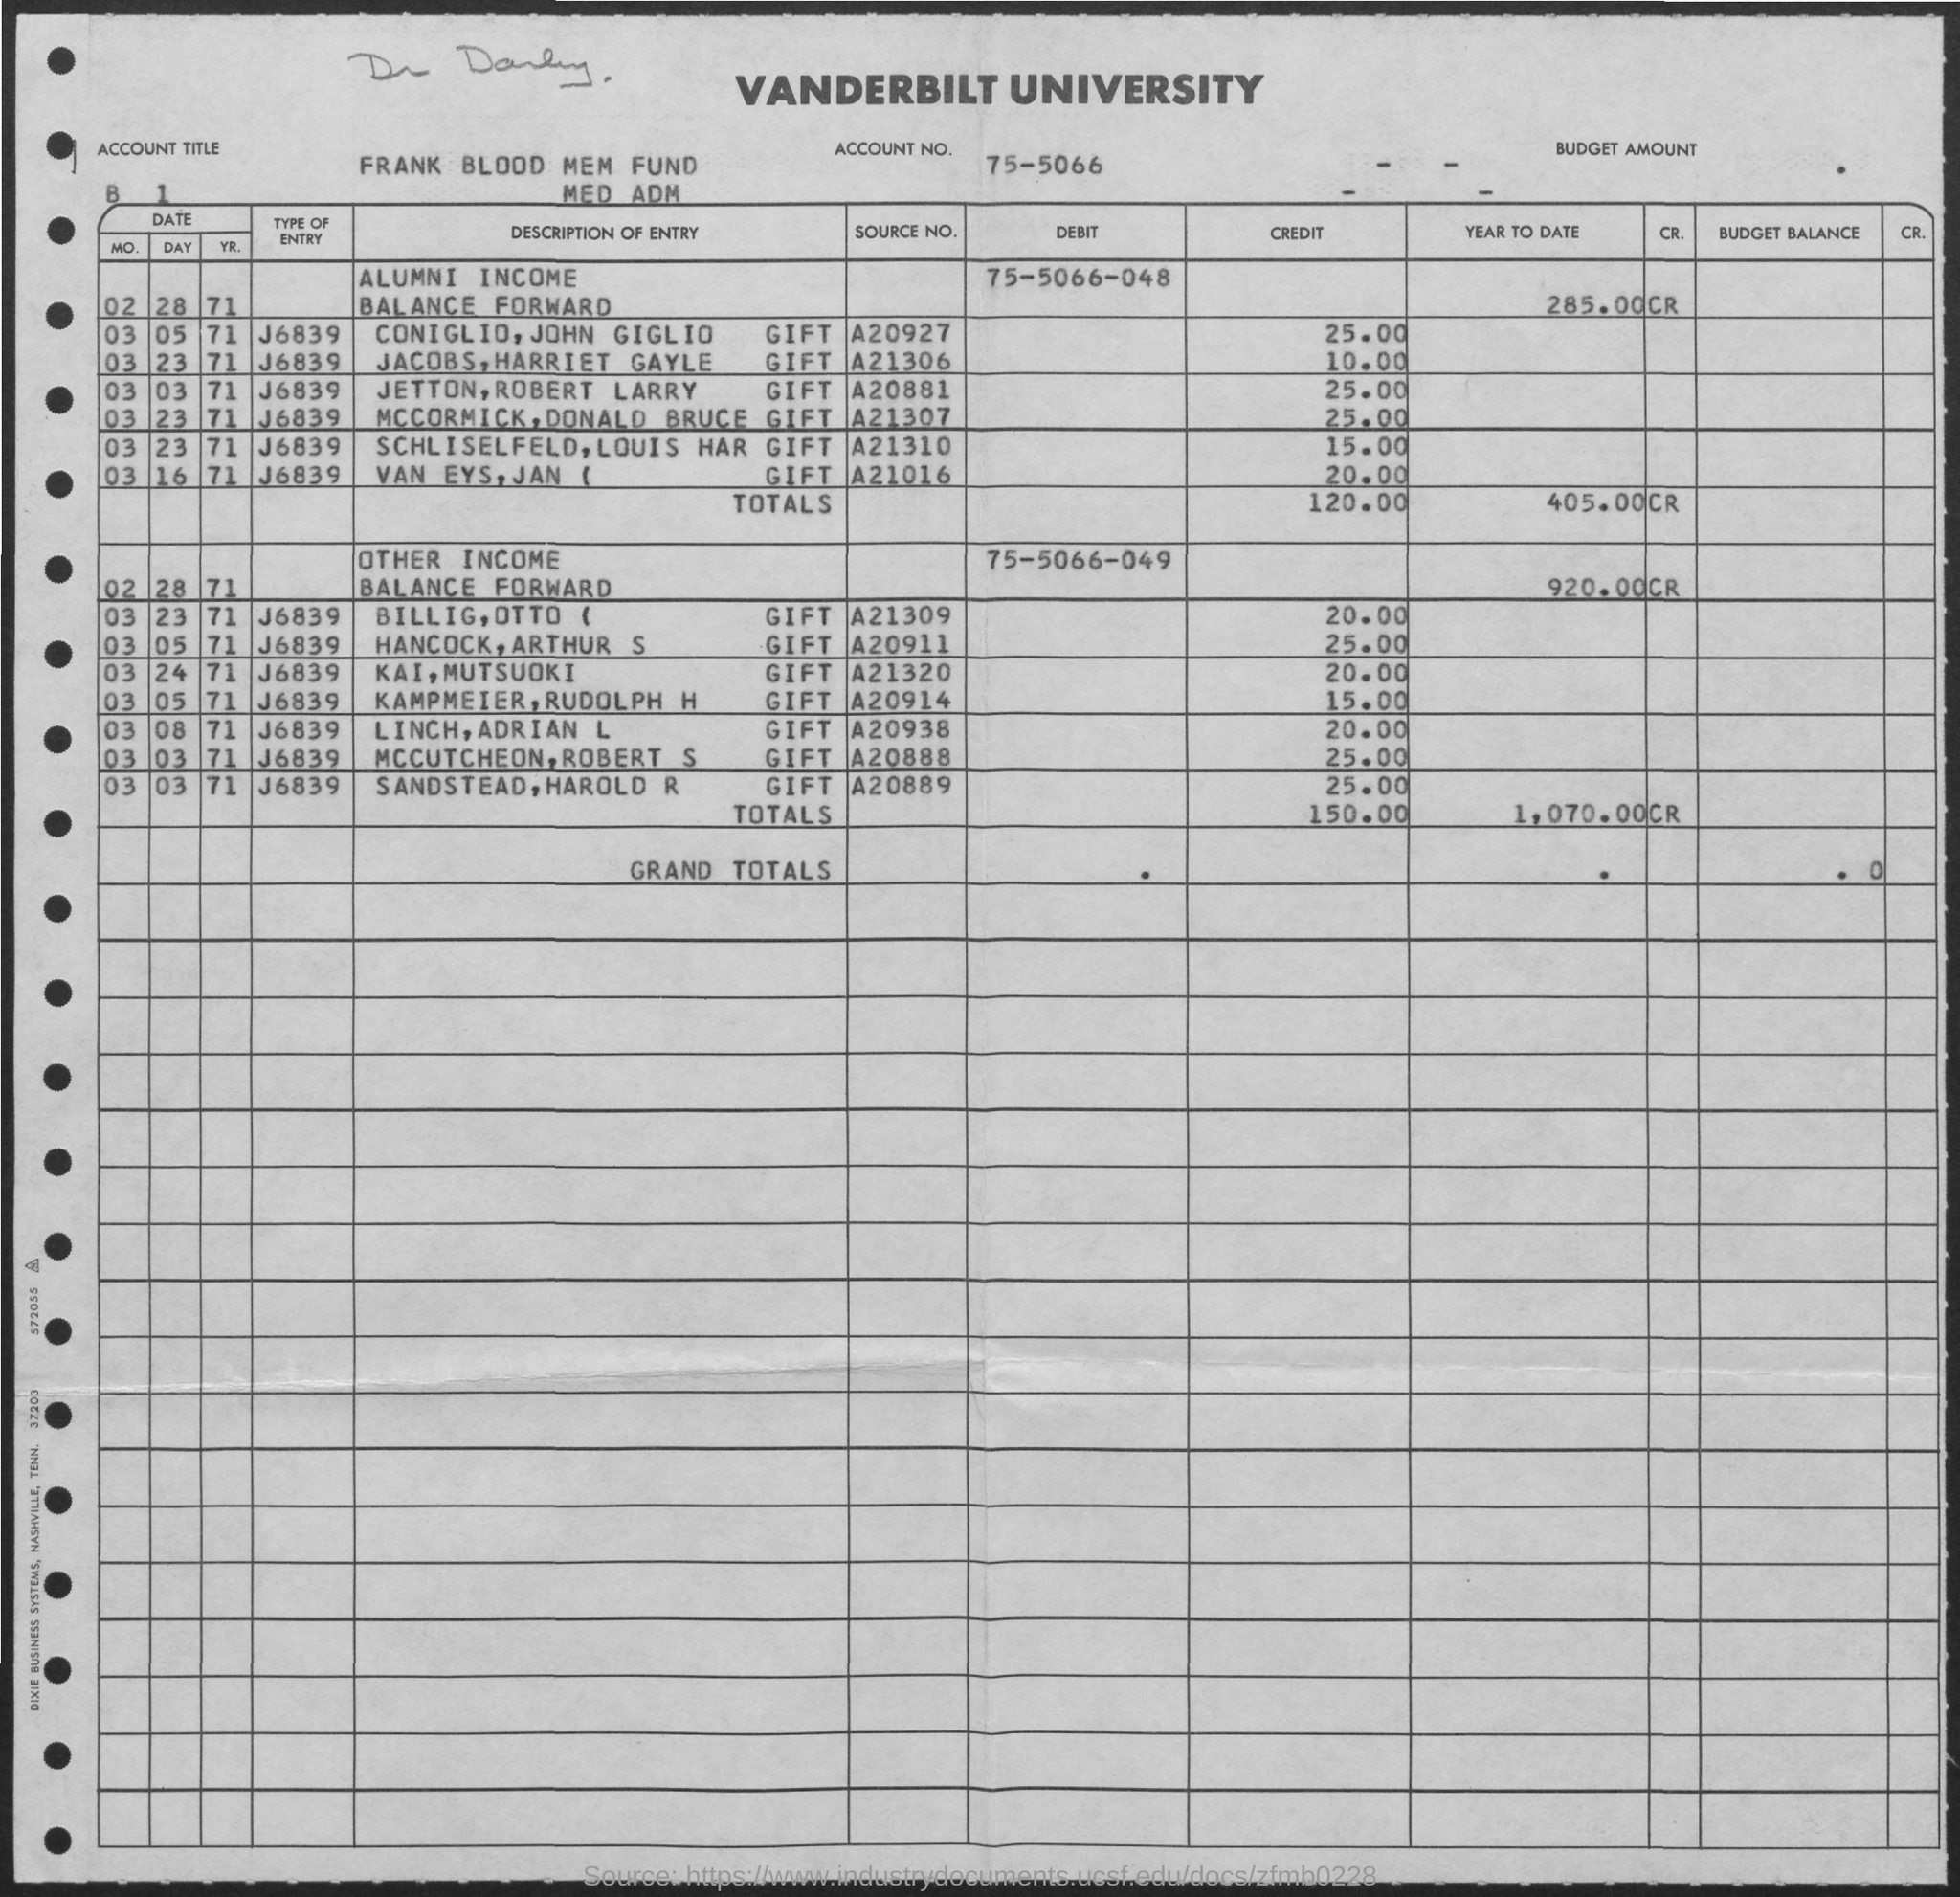Which university is mentioned on the document?
Your answer should be very brief. Vanderbilt university. What is the account title?
Keep it short and to the point. Frank blood mem fund. 